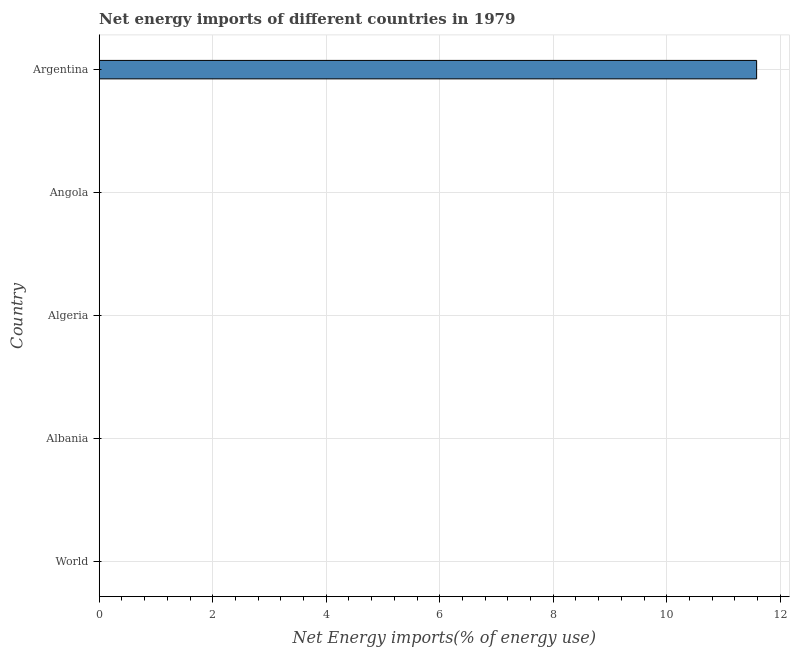Does the graph contain any zero values?
Ensure brevity in your answer.  Yes. Does the graph contain grids?
Offer a very short reply. Yes. What is the title of the graph?
Your response must be concise. Net energy imports of different countries in 1979. What is the label or title of the X-axis?
Make the answer very short. Net Energy imports(% of energy use). What is the label or title of the Y-axis?
Give a very brief answer. Country. Across all countries, what is the maximum energy imports?
Provide a short and direct response. 11.58. Across all countries, what is the minimum energy imports?
Give a very brief answer. 0. In which country was the energy imports maximum?
Offer a terse response. Argentina. What is the sum of the energy imports?
Your answer should be very brief. 11.58. What is the average energy imports per country?
Make the answer very short. 2.32. What is the median energy imports?
Provide a short and direct response. 0. What is the difference between the highest and the lowest energy imports?
Offer a very short reply. 11.58. Are all the bars in the graph horizontal?
Offer a terse response. Yes. How many countries are there in the graph?
Keep it short and to the point. 5. Are the values on the major ticks of X-axis written in scientific E-notation?
Offer a terse response. No. What is the Net Energy imports(% of energy use) of World?
Provide a short and direct response. 0. What is the Net Energy imports(% of energy use) of Albania?
Make the answer very short. 0. What is the Net Energy imports(% of energy use) of Argentina?
Offer a terse response. 11.58. 